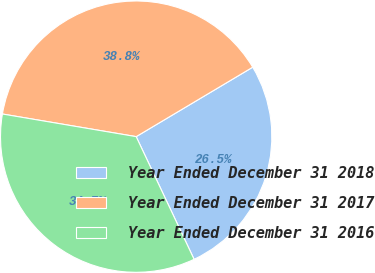Convert chart to OTSL. <chart><loc_0><loc_0><loc_500><loc_500><pie_chart><fcel>Year Ended December 31 2018<fcel>Year Ended December 31 2017<fcel>Year Ended December 31 2016<nl><fcel>26.53%<fcel>38.78%<fcel>34.69%<nl></chart> 